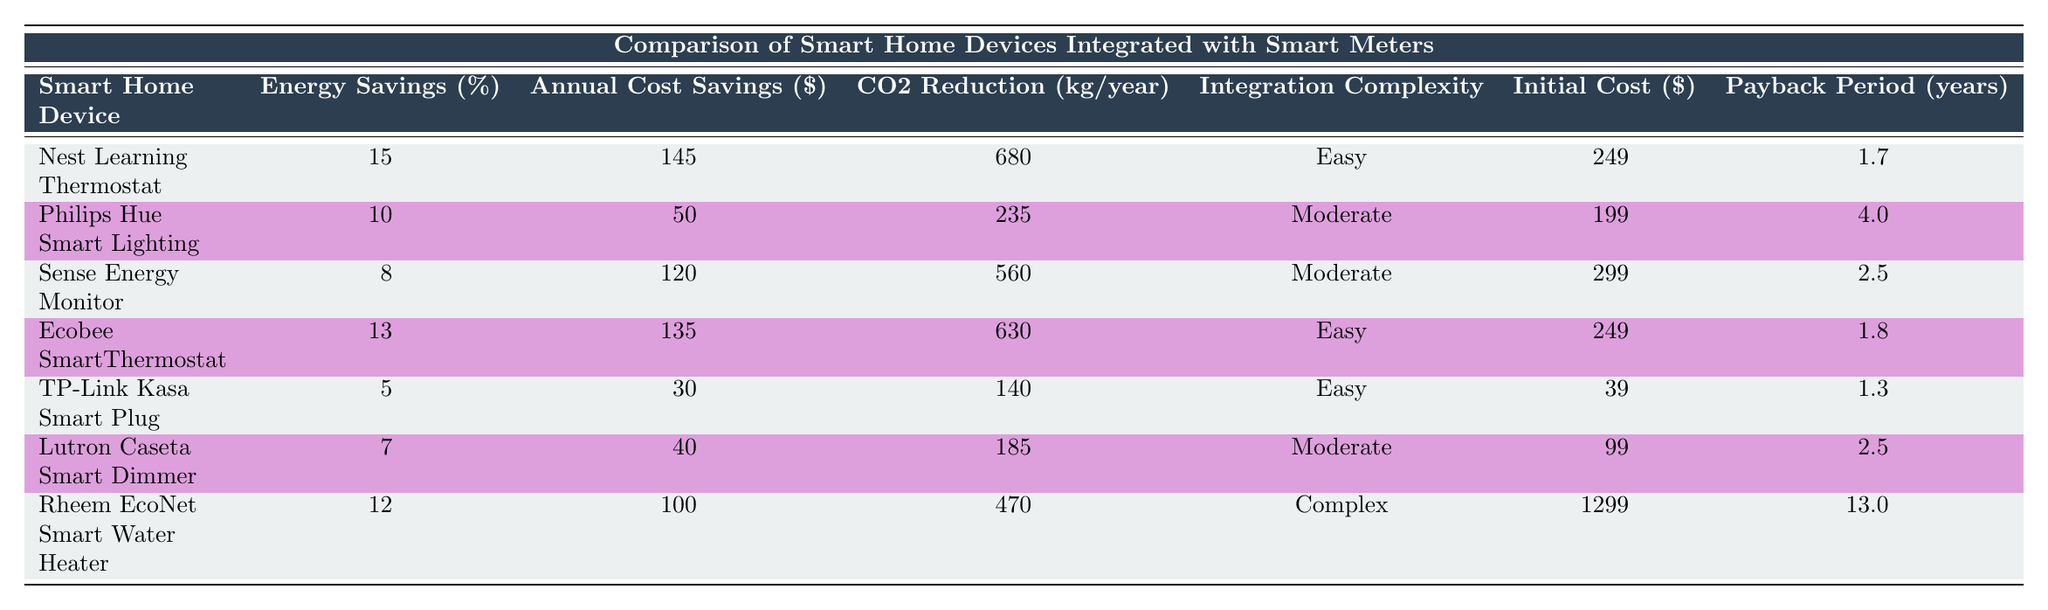What is the energy savings percentage of the Nest Learning Thermostat? The table shows that the energy savings percentage for the Nest Learning Thermostat is listed next to its name. Looking under the "Energy Savings (%)" column for that device yields 15%.
Answer: 15% Which device offers the highest annual cost savings? To find the device with the highest annual cost savings, I look across the "Annual Cost Savings ($)" column. The Nest Learning Thermostat has the highest savings of $145.
Answer: Nest Learning Thermostat What is the average payback period for all devices? To calculate the average payback period, I add all the payback periods together: (1.7 + 4.0 + 2.5 + 1.8 + 1.3 + 2.5 + 13.0) = 27.8 years. Then, I divide by the number of devices (7) to get the average: 27.8 / 7 ≈ 3.97 years.
Answer: 3.97 years Does the Lutron Caseta Smart Dimmer have a payback period longer than 2 years? I can check the "Payback Period (years)" column for the Lutron Caseta Smart Dimmer. Its payback period is 2.5 years, which is indeed longer than 2 years.
Answer: Yes Which smart home device has both the highest energy savings and the lowest integration complexity? The table shows that the Nest Learning Thermostat has the highest energy savings at 15% and an integration complexity level of "Easy." No other device matches this combination of high energy savings and low integration complexity.
Answer: Nest Learning Thermostat How much CO2 reduction does the Ecobee SmartThermostat achieve compared to the TP-Link Kasa Smart Plug? I look at the "CO2 Reduction (kg/year)" column for both devices. The Ecobee SmartThermostat shows 630 kg/year while the TP-Link Kasa Smart Plug shows 140 kg/year. The difference is 630 - 140 = 490 kg/year.
Answer: 490 kg/year Is the initial cost of the Rheem EcoNet Smart Water Heater lower than $1,000? The initial cost for the Rheem EcoNet Smart Water Heater is shown in the "Initial Cost ($)" column. It is listed as $1299, which is not lower than $1,000.
Answer: No 